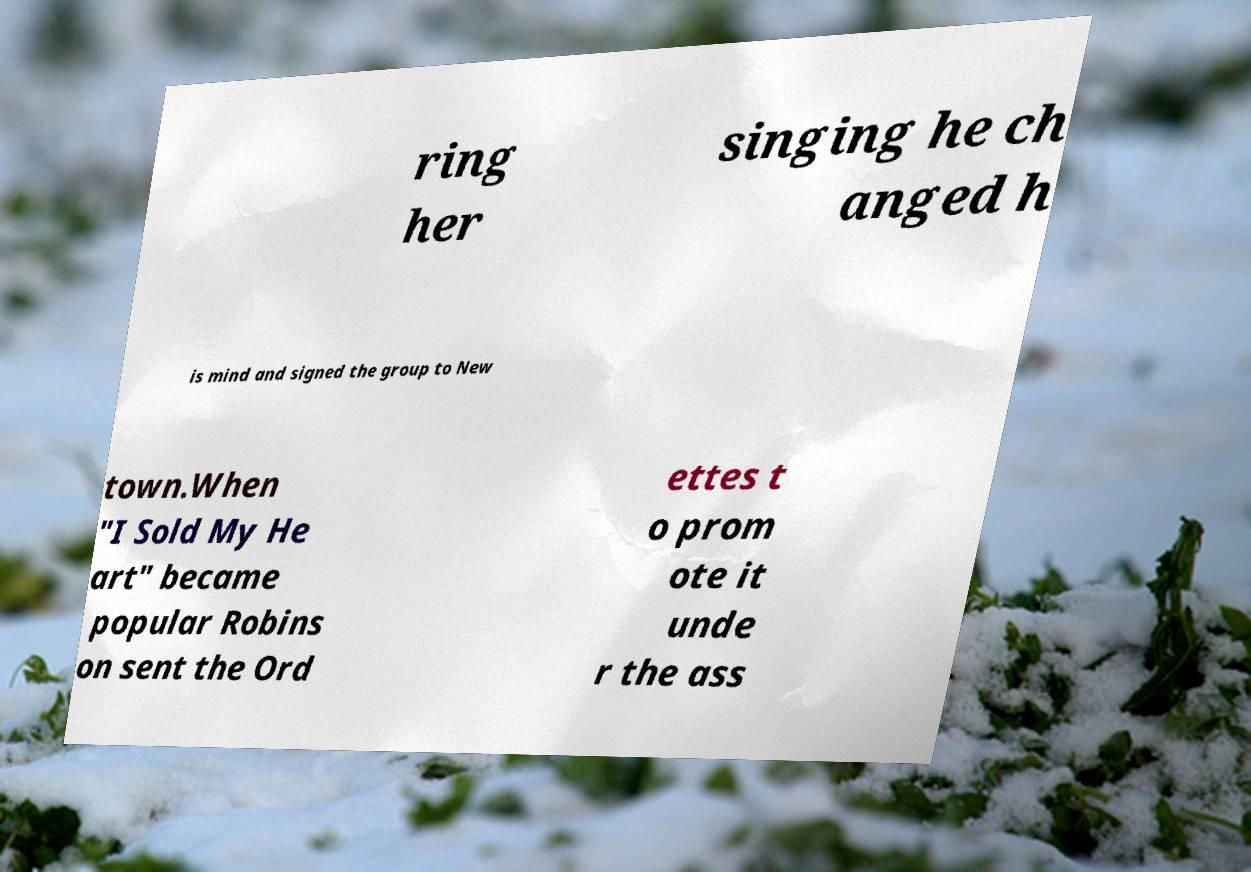Could you extract and type out the text from this image? ring her singing he ch anged h is mind and signed the group to New town.When "I Sold My He art" became popular Robins on sent the Ord ettes t o prom ote it unde r the ass 